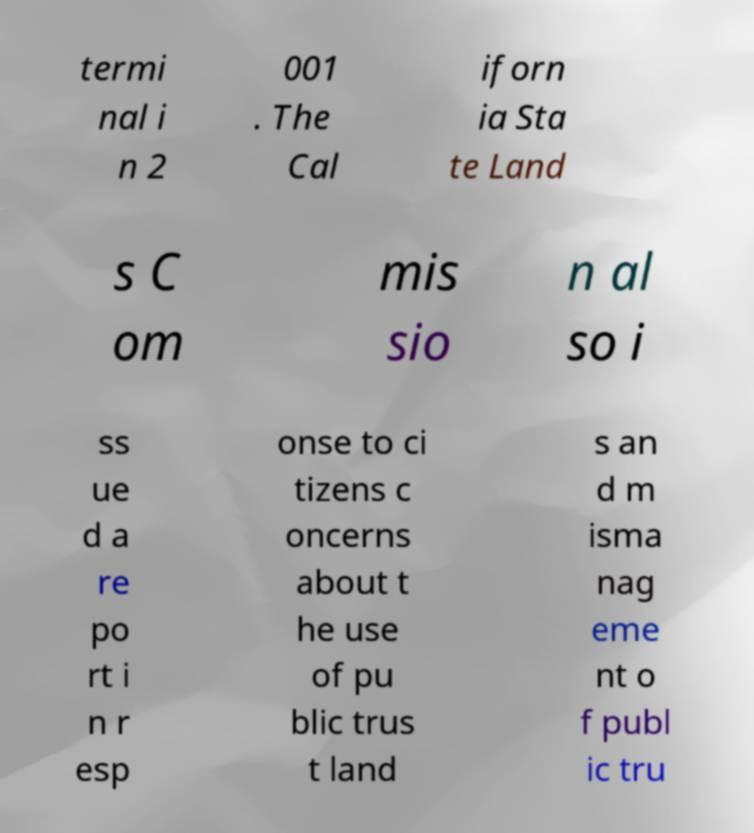There's text embedded in this image that I need extracted. Can you transcribe it verbatim? termi nal i n 2 001 . The Cal iforn ia Sta te Land s C om mis sio n al so i ss ue d a re po rt i n r esp onse to ci tizens c oncerns about t he use of pu blic trus t land s an d m isma nag eme nt o f publ ic tru 